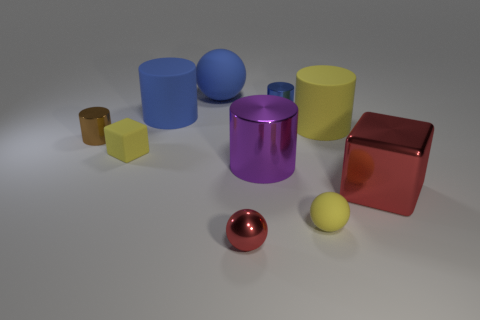Subtract all brown cylinders. How many cylinders are left? 4 Subtract all big metallic cylinders. How many cylinders are left? 4 Subtract all green cylinders. Subtract all green balls. How many cylinders are left? 5 Subtract all balls. How many objects are left? 7 Add 7 large blue objects. How many large blue objects are left? 9 Add 9 large purple things. How many large purple things exist? 10 Subtract 0 purple cubes. How many objects are left? 10 Subtract all large blue matte cylinders. Subtract all metallic objects. How many objects are left? 4 